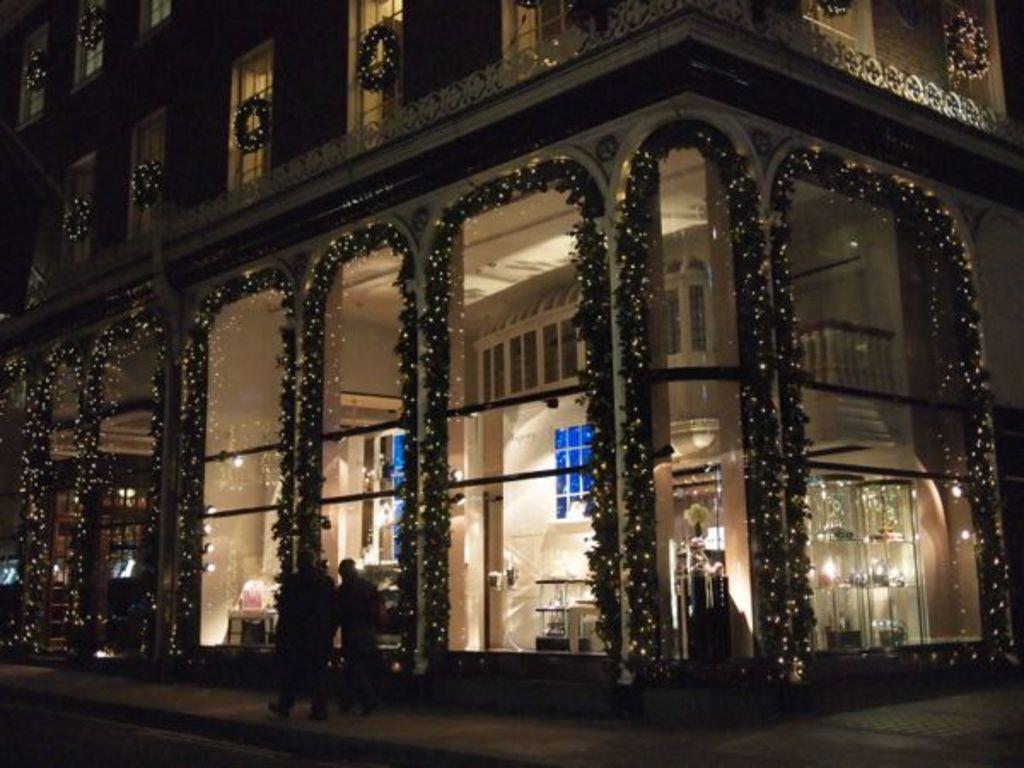Please provide a concise description of this image. In the image there is a building and it is beautifully decorated with lights and there are two people walking on the footpath in front of the building. 